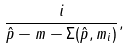<formula> <loc_0><loc_0><loc_500><loc_500>\frac { i } { \hat { p } - m - \Sigma ( \hat { p } , m _ { i } ) } ,</formula> 